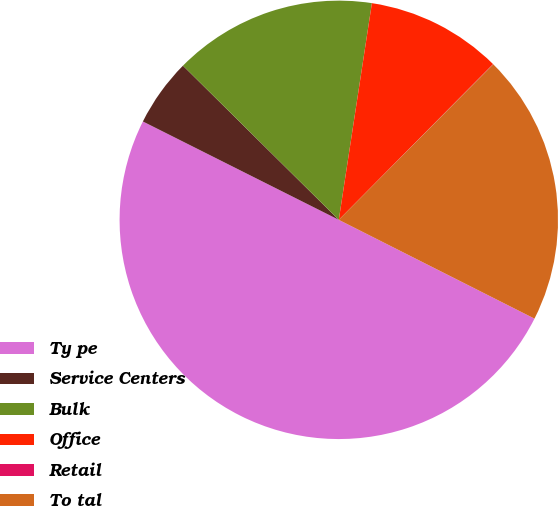Convert chart. <chart><loc_0><loc_0><loc_500><loc_500><pie_chart><fcel>Ty pe<fcel>Service Centers<fcel>Bulk<fcel>Office<fcel>Retail<fcel>To tal<nl><fcel>49.97%<fcel>5.01%<fcel>15.0%<fcel>10.01%<fcel>0.02%<fcel>20.0%<nl></chart> 